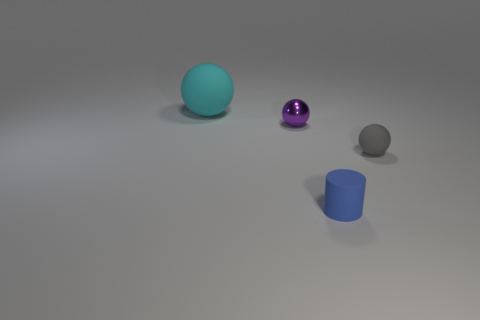What might be the textures of the objects shown? The cyan sphere seems to have a rubber-like texture, given its matte finish and the way it diffuses light. The purple sphere appears polished or metallic due to its reflective surface. The gray sphere also has a matte texture, but it seems rougher than the cyan one. The blue cylinder looks solid with a matte finish, possibly of a plastic or painted metal material. 